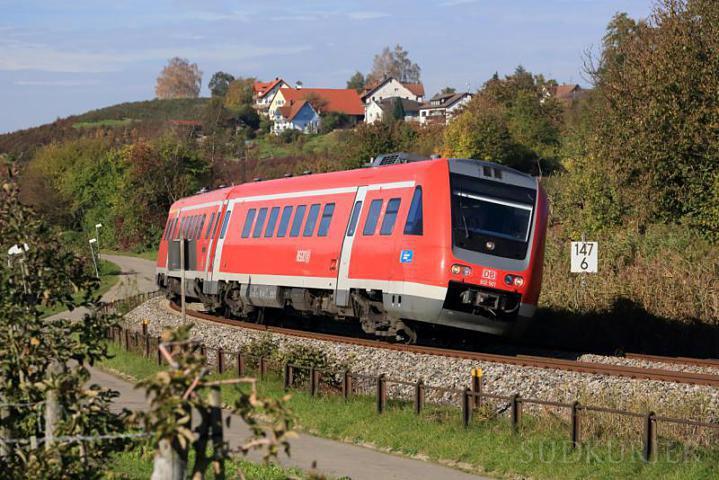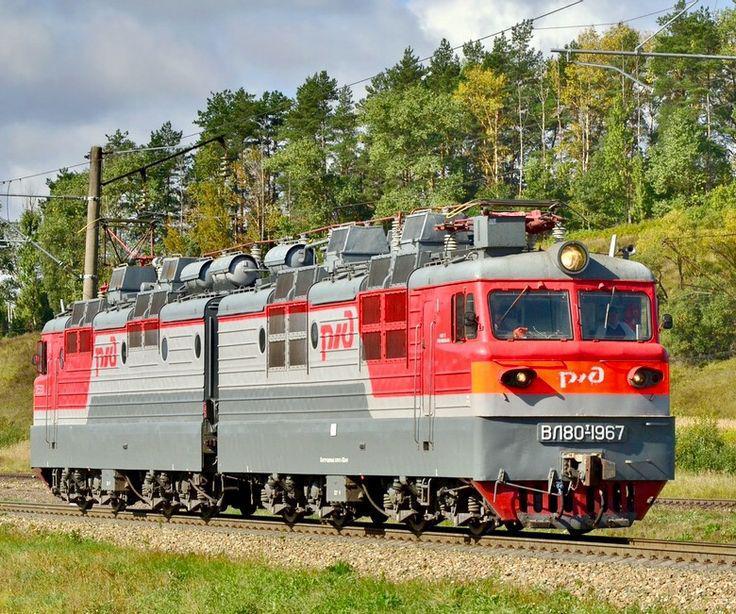The first image is the image on the left, the second image is the image on the right. For the images shown, is this caption "Both trains are facing and traveling to the right." true? Answer yes or no. Yes. The first image is the image on the left, the second image is the image on the right. Evaluate the accuracy of this statement regarding the images: "An image shows a dark green train with bright orange stripes across the front.". Is it true? Answer yes or no. No. 